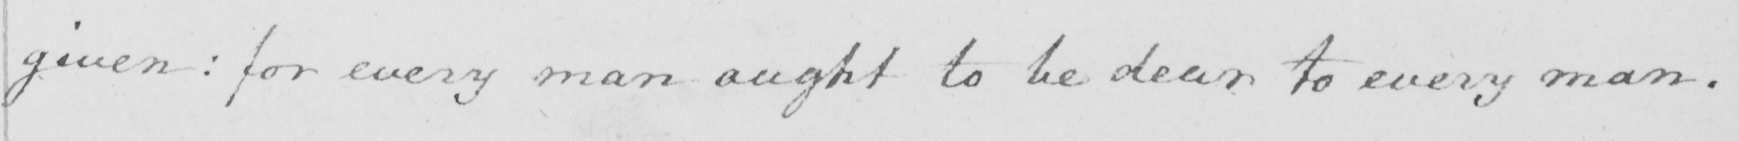Can you read and transcribe this handwriting? given: for every man ought to be dear to every man. 